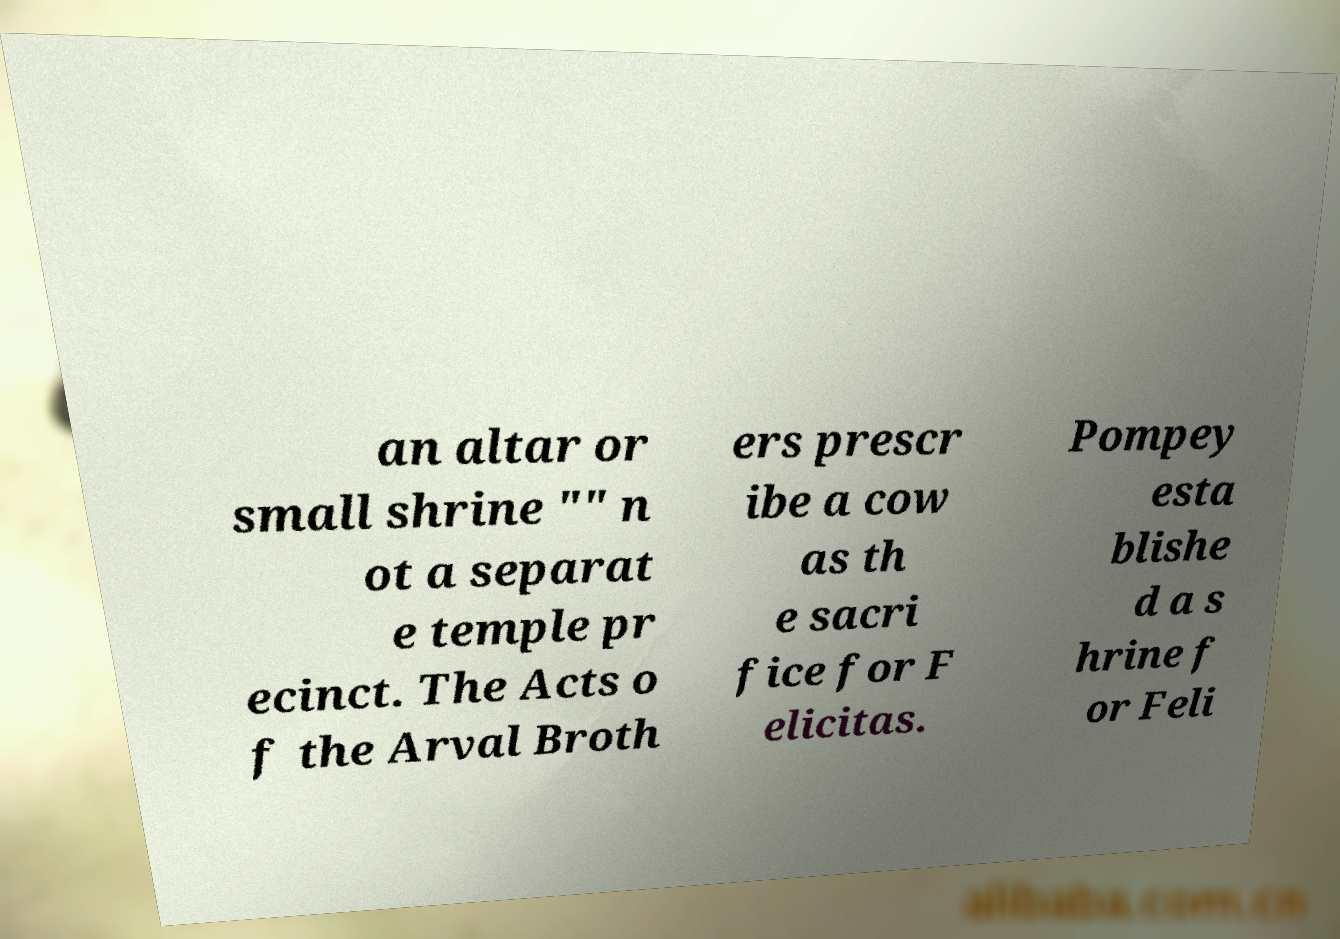Please read and relay the text visible in this image. What does it say? an altar or small shrine "" n ot a separat e temple pr ecinct. The Acts o f the Arval Broth ers prescr ibe a cow as th e sacri fice for F elicitas. Pompey esta blishe d a s hrine f or Feli 